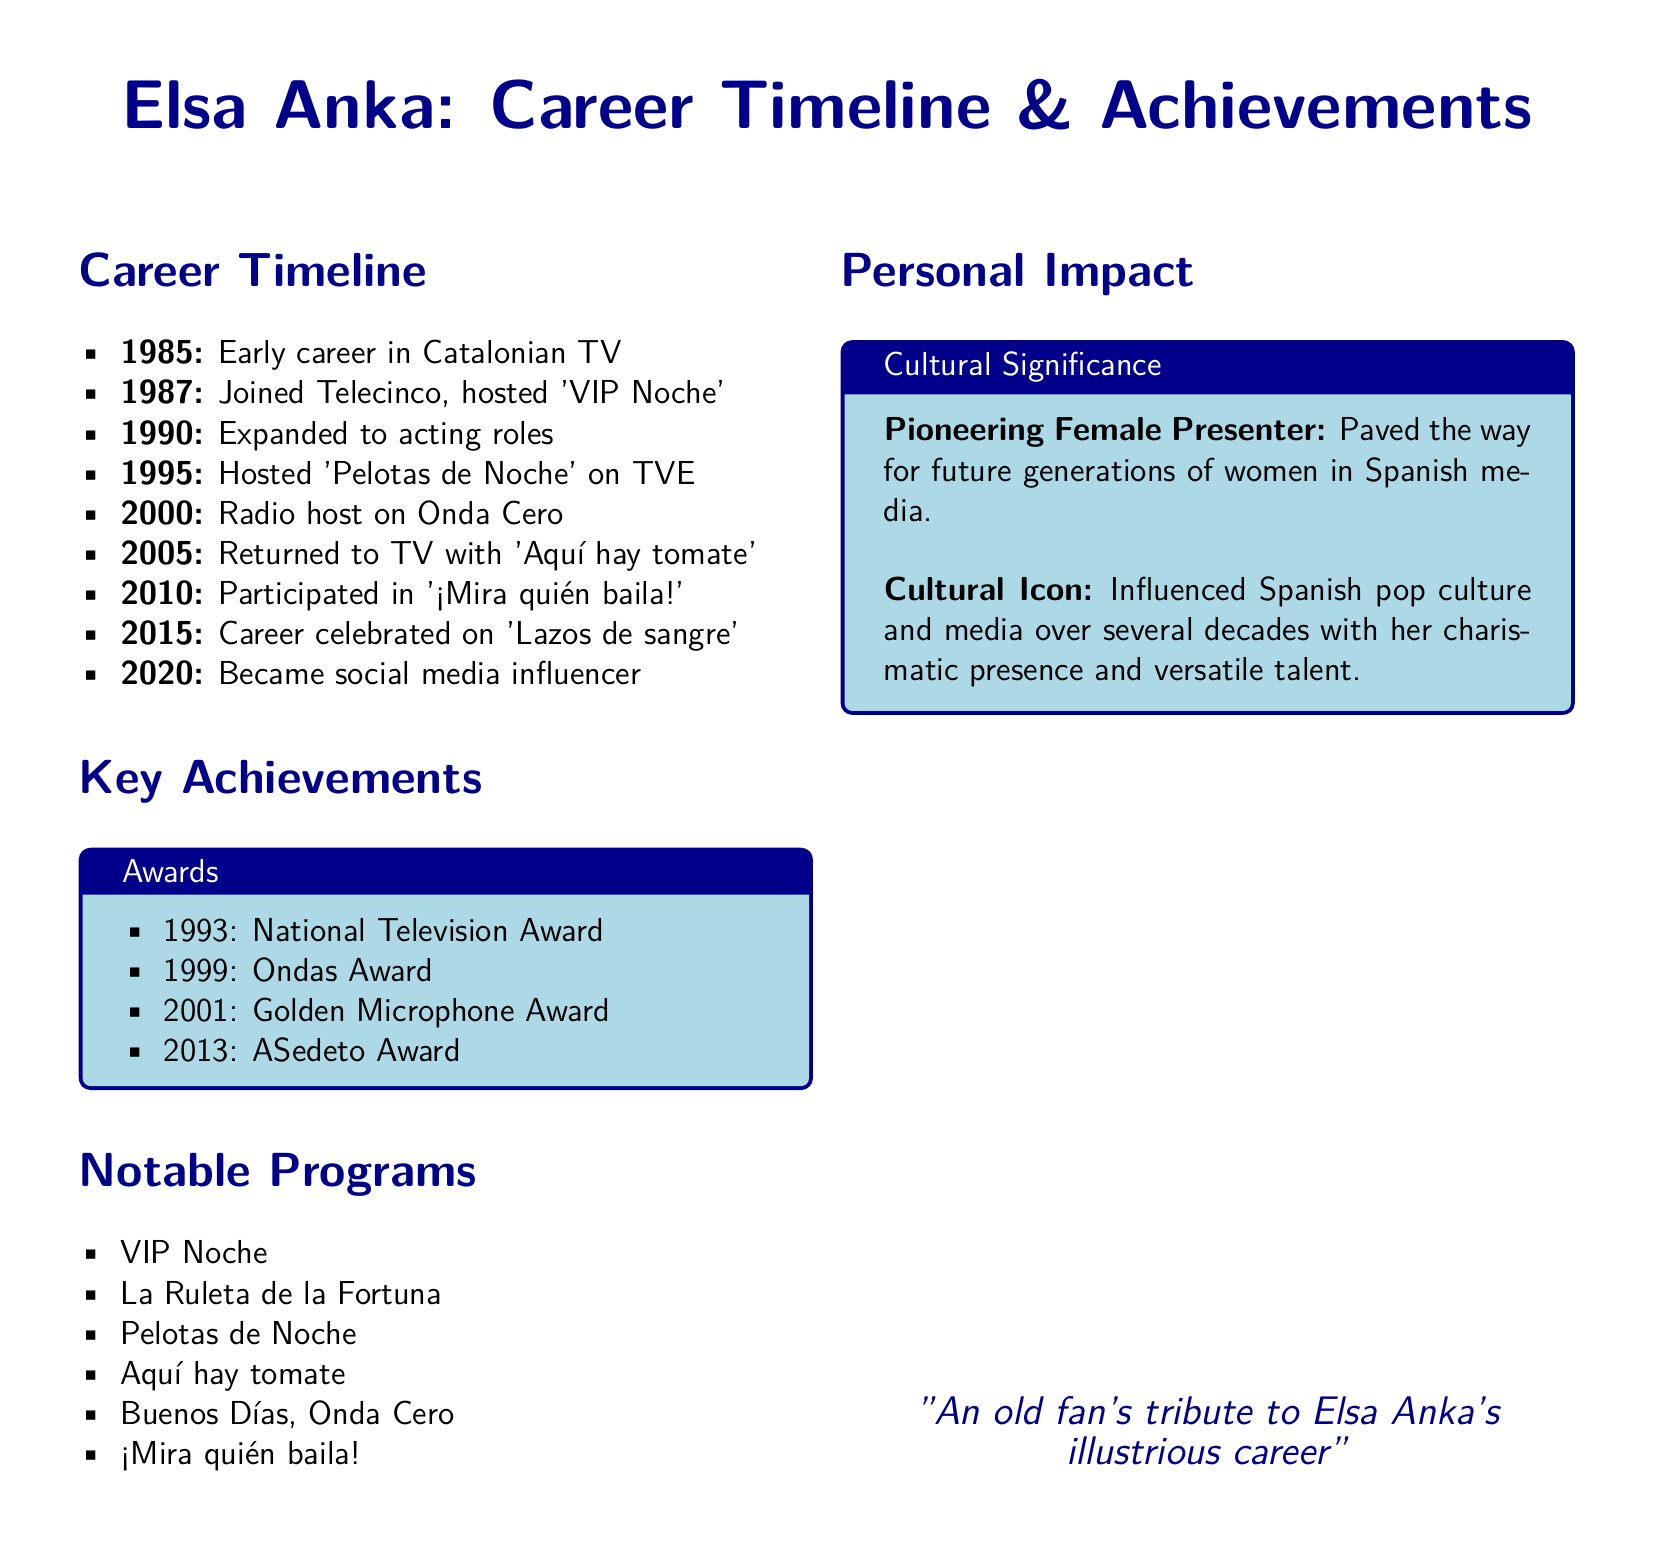What year did Elsa Anka start her career? The document states that she began her early career in Catalonian TV in 1985.
Answer: 1985 What program did Elsa Anka host on Telecinco? It is mentioned that she hosted 'VIP Noche' after joining Telecinco in 1987.
Answer: VIP Noche How many awards did Elsa Anka receive according to the document? The document lists four specific awards she received throughout her career.
Answer: 4 Which award did Elsa Anka receive in 2001? The document specifically states that she received the Golden Microphone Award in that year.
Answer: Golden Microphone Award What significant event occurred in Elsa Anka's career in 2015? The document notes that her career was celebrated on the show 'Lazos de sangre' in that year.
Answer: Lazos de sangre What role did Elsa Anka play in Spanish media? The document describes her as a pioneering female presenter influencing future generations in the media.
Answer: Pioneering Female Presenter In what year did Elsa Anka become a social media influencer? According to the document, she became a social media influencer in 2020.
Answer: 2020 What type of document is this? This document provides a summary of a person's career milestones, achievements, and impact.
Answer: Datasheet Which notable program aired in 2005 featuring Elsa Anka? The document lists 'Aquí hay tomate' as a program she returned to in that year.
Answer: Aquí hay tomate 